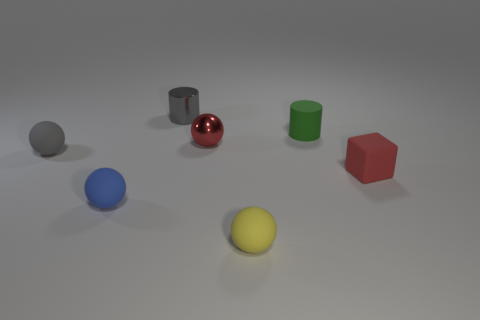Add 2 cyan objects. How many objects exist? 9 Subtract all small matte balls. How many balls are left? 1 Subtract 1 cylinders. How many cylinders are left? 1 Subtract all green cylinders. How many cylinders are left? 1 Subtract all spheres. How many objects are left? 3 Add 4 tiny gray spheres. How many tiny gray spheres are left? 5 Add 4 blue matte things. How many blue matte things exist? 5 Subtract 1 gray cylinders. How many objects are left? 6 Subtract all purple cylinders. Subtract all cyan blocks. How many cylinders are left? 2 Subtract all large gray metal balls. Subtract all tiny gray metal cylinders. How many objects are left? 6 